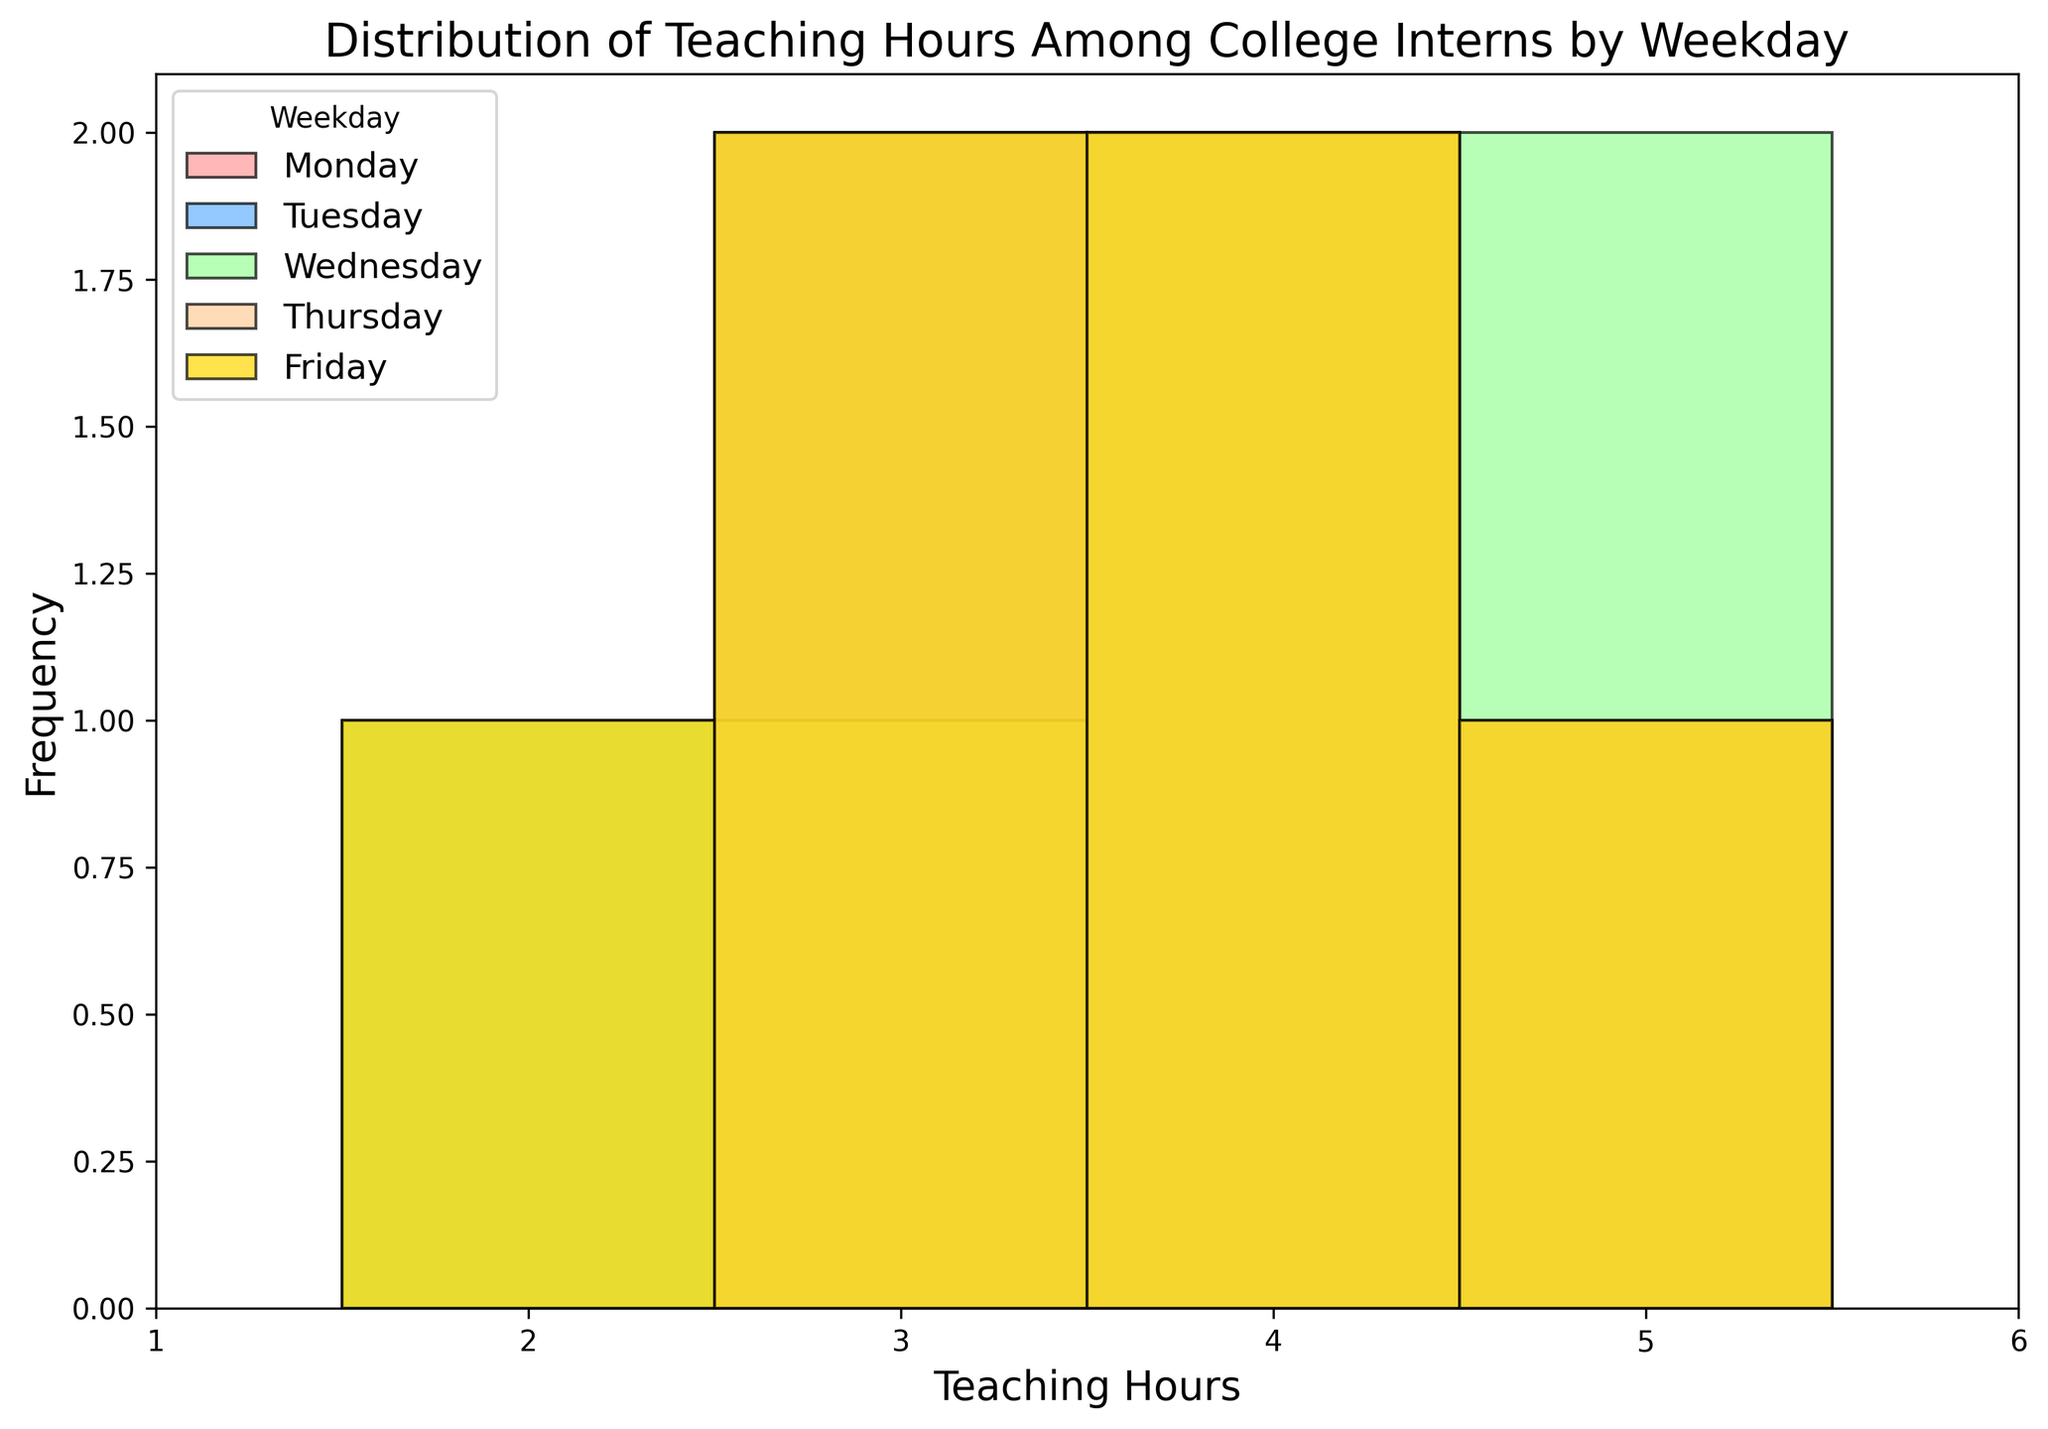What weekday shows the highest frequency of having 4 teaching hours? By examining the histogram bars, find the bar corresponding to 4 teaching hours for each weekday, and observe which one reaches the highest frequency.
Answer: Wednesday Compare the frequency of interns teaching for 2 hours on Wednesday with those teaching for 2 hours on Monday. Which one is higher? Locate the bars representing 2 teaching hours for both Wednesday and Monday in the histogram, then compare their heights.
Answer: Monday What is the range of teaching hours observed in the data? Identify the minimum and maximum values of teaching hours on the x-axis in the histogram.
Answer: 2 to 6 On which weekday do interns have the most diverse range of teaching hours? Examine the spread of bars for each weekday to see which one covers the widest range of integers on the x-axis.
Answer: Thursday Which day's distribution of teaching hours appears most consistent, without extreme variations in frequencies? Look for a weekday where the histogram bars are relatively even in height across different hours, indicating consistent teaching hours.
Answer: Friday What is the most common teaching hour for interns on Tuesday? Observe the highest bar for Tuesday in the histogram to identify the teaching hour it represents.
Answer: 3 and 4 (both are common) Compare the frequency of interns teaching for 3 hours on Thursday to those teaching for 3 hours on Friday. locate the 3 hour bars for both Thursday and Friday and compare their heights.
Answer: They are equal Which weekday has the lowest occurrence of 6 teaching hours? Identify the bar for 6 teaching hours for each weekday and determine which one is the shortest or non-existent.
Answer: Monday and Friday What is the median teaching hour for Wednesday? List the teaching hours for Wednesday and find the middle value when sorted. Given the even number, the median is calculated as the average of the two middle values (3 and 4).
Answer: 3.5 Which day has the most concentrated teaching hours near the lower end of the range (specifically 2 and 3 hours)? Compare the frequencies of 2 and 3-hour bars across all weekdays and note the weekday with the highest frequencies combined.
Answer: Monday 